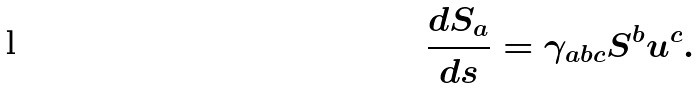Convert formula to latex. <formula><loc_0><loc_0><loc_500><loc_500>\frac { d S _ { a } } { d s } = \gamma _ { a b c } S ^ { b } u ^ { c } .</formula> 